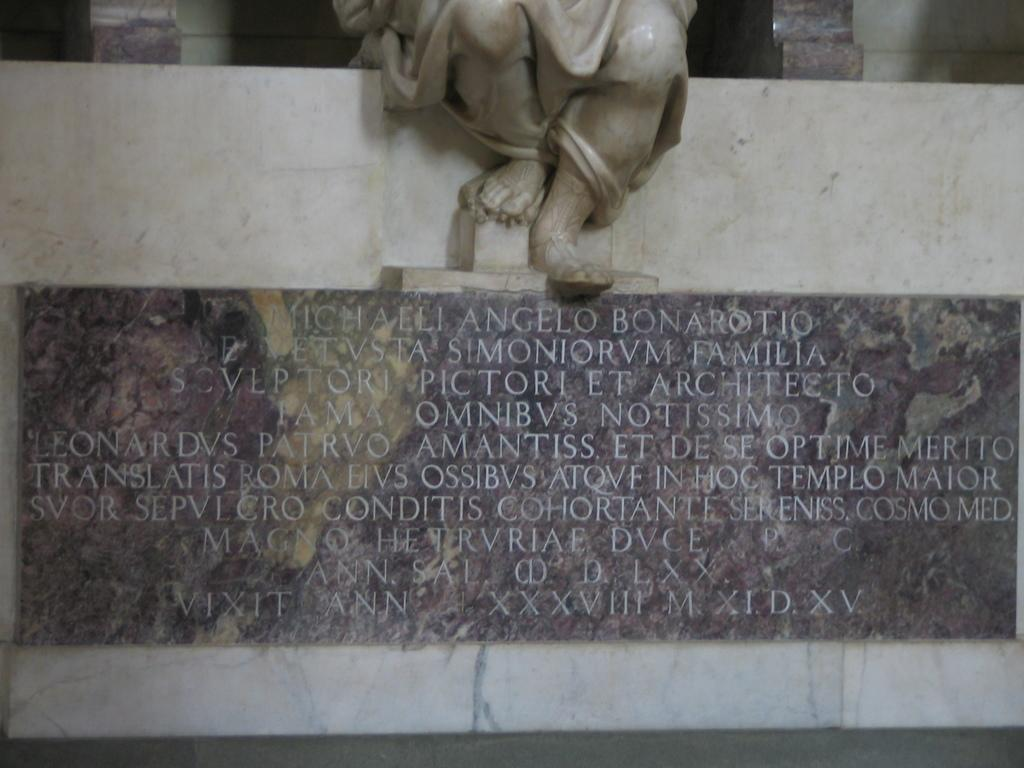What can be seen on the wall in the image? There is carved text on the wall in the image. What other object is present in the image? There is a statue in the image. Is there any smoke coming from the statue in the image? No, there is no smoke present in the image. What type of pen is being used to write the carved text on the wall? There is no pen visible in the image, as the text is carved, not written. 